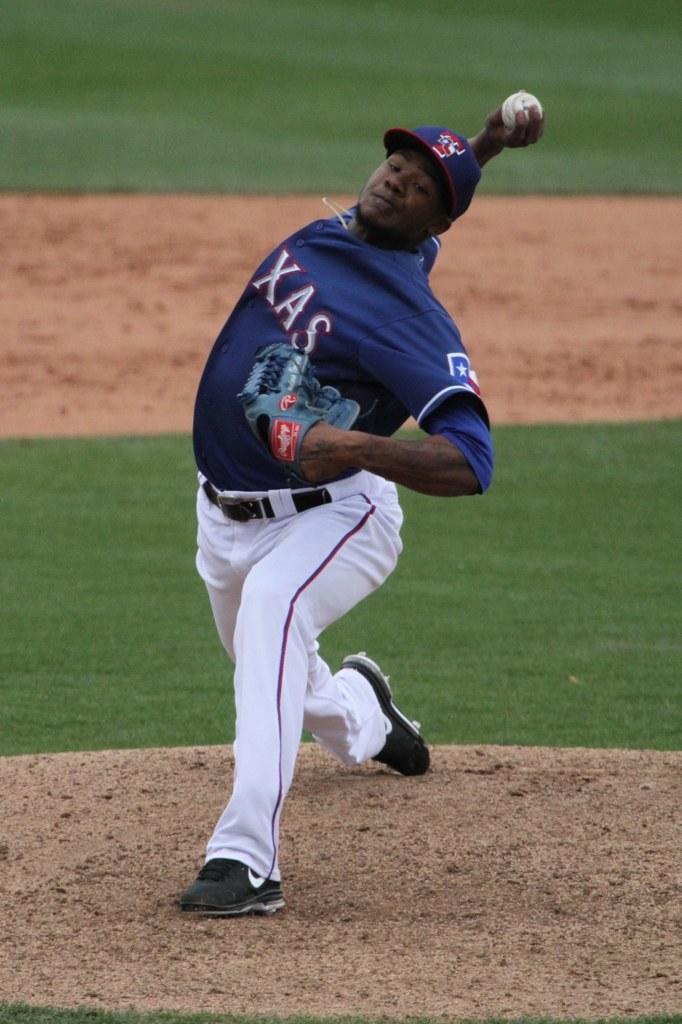What kind of ball is in his hand?
Your answer should be compact. Baseball. 